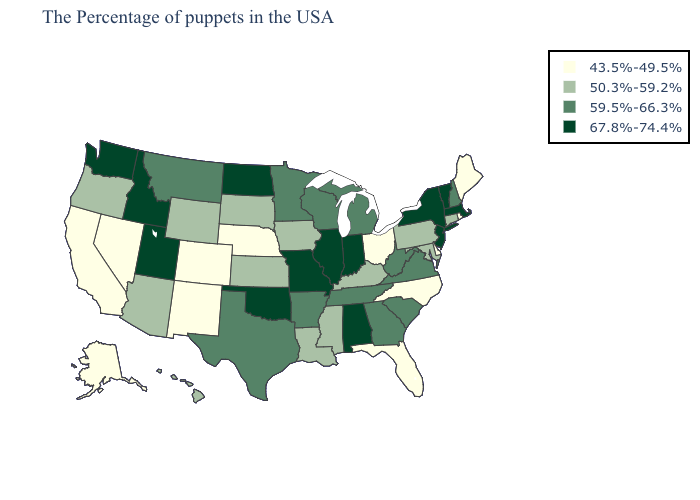What is the lowest value in the USA?
Quick response, please. 43.5%-49.5%. Name the states that have a value in the range 43.5%-49.5%?
Answer briefly. Maine, Rhode Island, Delaware, North Carolina, Ohio, Florida, Nebraska, Colorado, New Mexico, Nevada, California, Alaska. What is the highest value in states that border Kentucky?
Give a very brief answer. 67.8%-74.4%. Does the map have missing data?
Short answer required. No. Name the states that have a value in the range 59.5%-66.3%?
Write a very short answer. New Hampshire, Virginia, South Carolina, West Virginia, Georgia, Michigan, Tennessee, Wisconsin, Arkansas, Minnesota, Texas, Montana. Name the states that have a value in the range 43.5%-49.5%?
Answer briefly. Maine, Rhode Island, Delaware, North Carolina, Ohio, Florida, Nebraska, Colorado, New Mexico, Nevada, California, Alaska. Which states have the highest value in the USA?
Quick response, please. Massachusetts, Vermont, New York, New Jersey, Indiana, Alabama, Illinois, Missouri, Oklahoma, North Dakota, Utah, Idaho, Washington. What is the value of Tennessee?
Give a very brief answer. 59.5%-66.3%. Which states hav the highest value in the Northeast?
Give a very brief answer. Massachusetts, Vermont, New York, New Jersey. Name the states that have a value in the range 59.5%-66.3%?
Give a very brief answer. New Hampshire, Virginia, South Carolina, West Virginia, Georgia, Michigan, Tennessee, Wisconsin, Arkansas, Minnesota, Texas, Montana. Name the states that have a value in the range 59.5%-66.3%?
Keep it brief. New Hampshire, Virginia, South Carolina, West Virginia, Georgia, Michigan, Tennessee, Wisconsin, Arkansas, Minnesota, Texas, Montana. Is the legend a continuous bar?
Short answer required. No. Among the states that border Texas , which have the highest value?
Quick response, please. Oklahoma. Does Connecticut have a higher value than Alaska?
Write a very short answer. Yes. Among the states that border Nebraska , does Missouri have the highest value?
Quick response, please. Yes. 